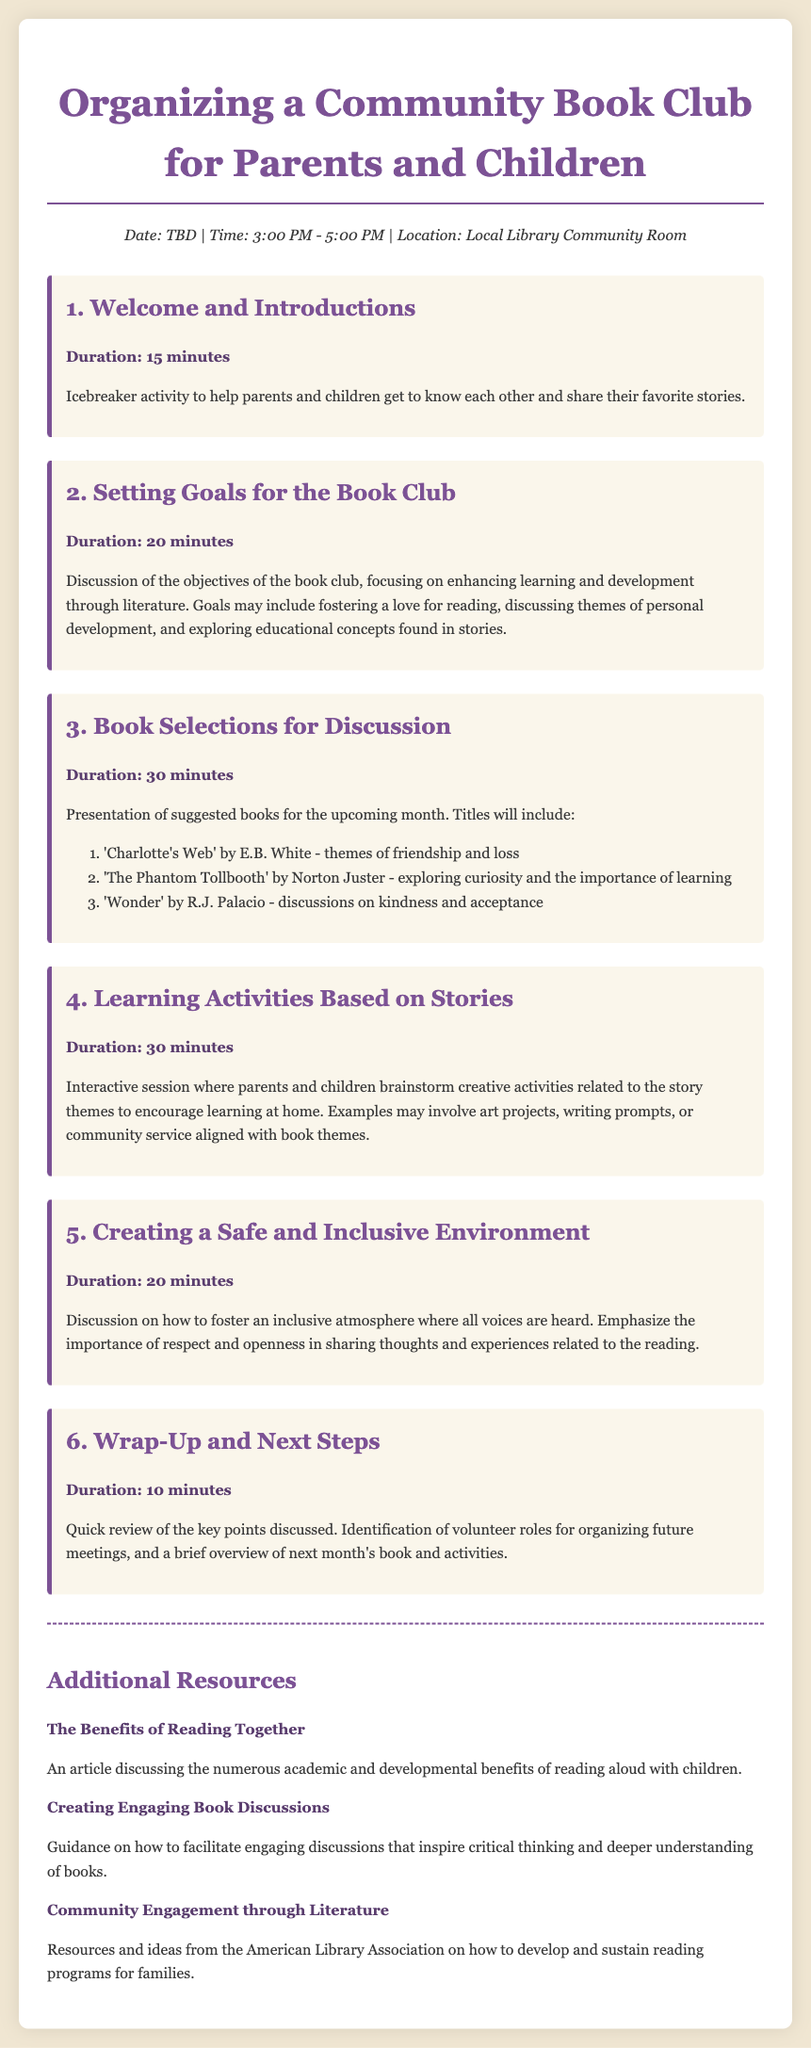What is the date of the book club meeting? The date of the book club meeting is marked as TBD in the document.
Answer: TBD What is the location of the event? The location specified for the event is the Local Library Community Room.
Answer: Local Library Community Room Name one of the suggested books for discussion. The document lists 'Charlotte's Web' by E.B. White as one of the suggested books.
Answer: 'Charlotte's Web' How long is the "Wrap-Up and Next Steps" session? The duration for the "Wrap-Up and Next Steps" session is indicated as 10 minutes.
Answer: 10 minutes What is the main focus of the book club according to the agenda? The agenda states that the main focus of the book club is enhancing learning and development through literature.
Answer: Enhancing learning and development through literature How many minutes are allocated for "Setting Goals for the Book Club"? The document allocates 20 minutes for "Setting Goals for the Book Club".
Answer: 20 minutes What type of activities are discussed in section 4? Section 4 discusses learning activities related to story themes.
Answer: Learning activities What is emphasized in the "Creating a Safe and Inclusive Environment" section? This section emphasizes the importance of respect and openness in sharing thoughts and experiences.
Answer: Respect and openness What is one of the resources mentioned for additional reading? The document mentions "The Benefits of Reading Together" as one of the additional resources.
Answer: The Benefits of Reading Together 